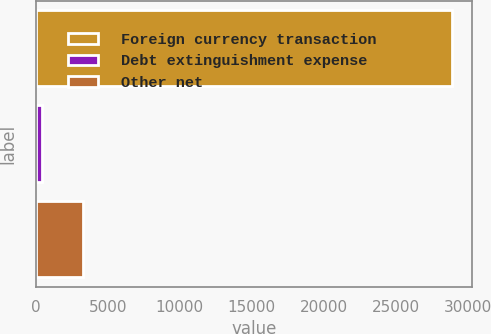Convert chart. <chart><loc_0><loc_0><loc_500><loc_500><bar_chart><fcel>Foreign currency transaction<fcel>Debt extinguishment expense<fcel>Other net<nl><fcel>28882<fcel>418<fcel>3264.4<nl></chart> 